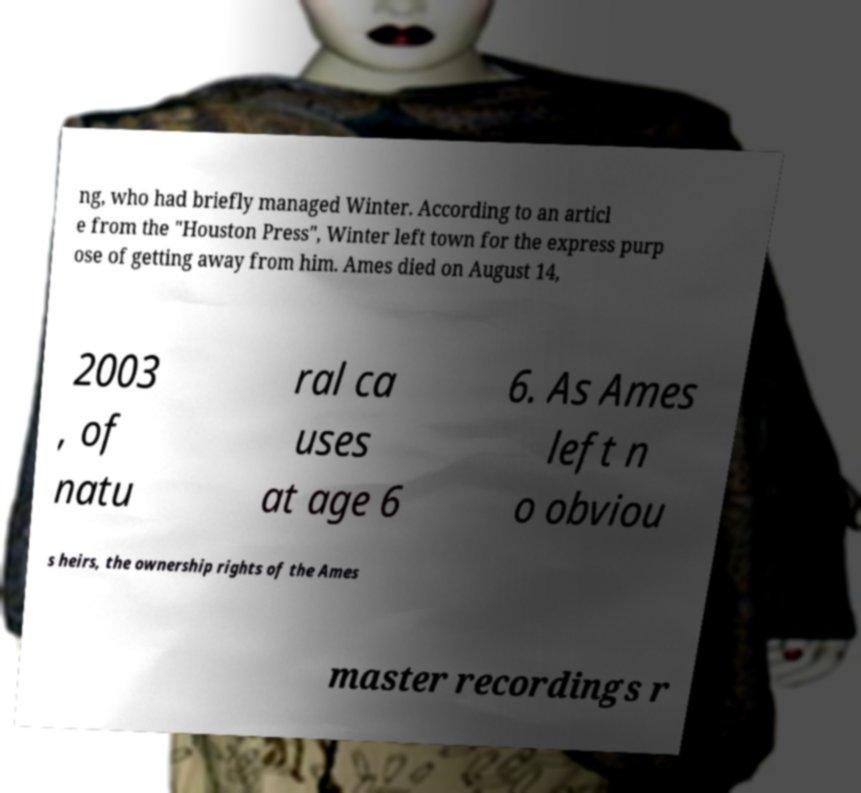I need the written content from this picture converted into text. Can you do that? ng, who had briefly managed Winter. According to an articl e from the "Houston Press", Winter left town for the express purp ose of getting away from him. Ames died on August 14, 2003 , of natu ral ca uses at age 6 6. As Ames left n o obviou s heirs, the ownership rights of the Ames master recordings r 